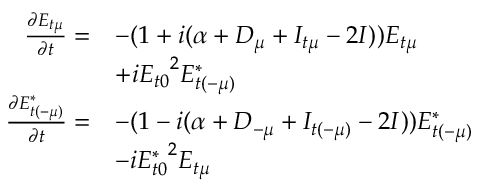Convert formula to latex. <formula><loc_0><loc_0><loc_500><loc_500>\begin{array} { r l } { \frac { \partial E _ { t \mu } } { \partial t } = } & { - ( 1 + i ( \alpha + D _ { \mu } + I _ { t \mu } - 2 I ) ) E _ { t \mu } } \\ & { + i { E _ { t 0 } } ^ { 2 } E _ { t ( - \mu ) } ^ { * } } \\ { \frac { \partial E _ { t ( - \mu ) } ^ { * } } { \partial t } = } & { - ( 1 - i ( \alpha + D _ { - \mu } + I _ { t ( - \mu ) } - 2 I ) ) E _ { t ( - \mu ) } ^ { * } } \\ & { - i { E _ { t 0 } ^ { * } } ^ { 2 } E _ { t \mu } } \end{array}</formula> 